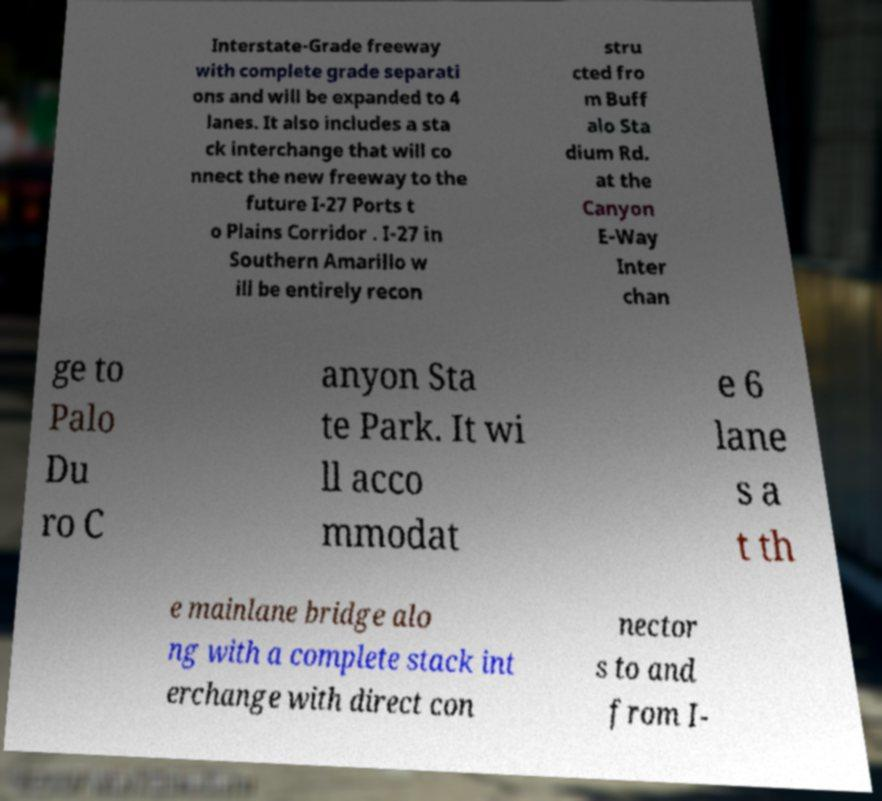For documentation purposes, I need the text within this image transcribed. Could you provide that? Interstate-Grade freeway with complete grade separati ons and will be expanded to 4 lanes. It also includes a sta ck interchange that will co nnect the new freeway to the future I-27 Ports t o Plains Corridor . I-27 in Southern Amarillo w ill be entirely recon stru cted fro m Buff alo Sta dium Rd. at the Canyon E-Way Inter chan ge to Palo Du ro C anyon Sta te Park. It wi ll acco mmodat e 6 lane s a t th e mainlane bridge alo ng with a complete stack int erchange with direct con nector s to and from I- 